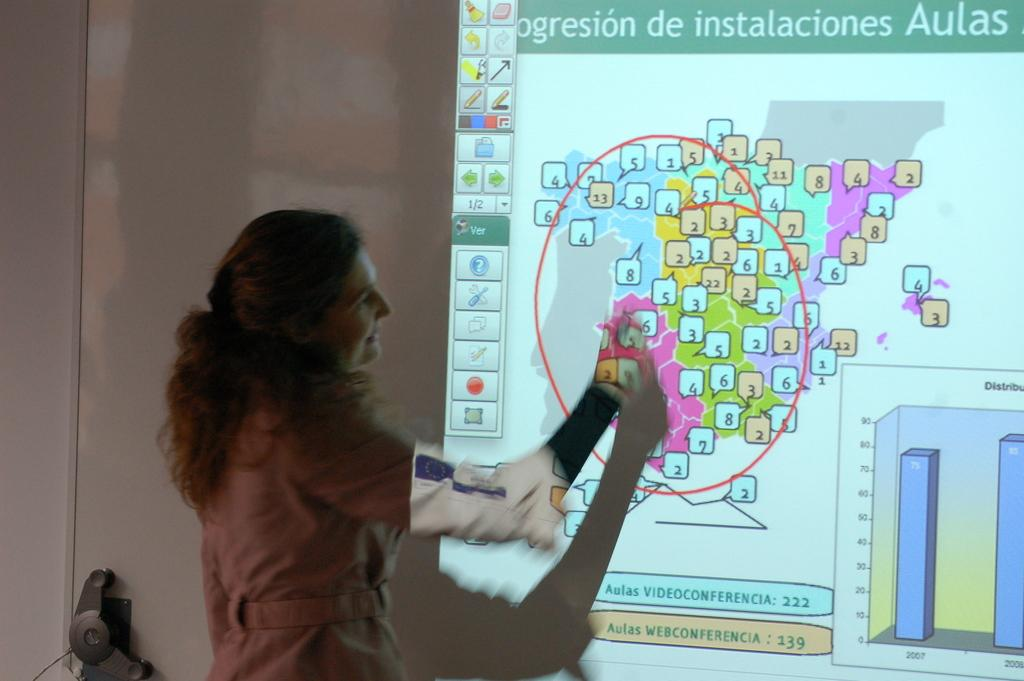Who is present in the image? There is a woman in the image. What can be seen in the background of the image? There is a projector screen in the background of the image. What type of vessel is being played by the woman in the image? There is no vessel or musical instrument present in the image; it only features a woman and a projector screen. 